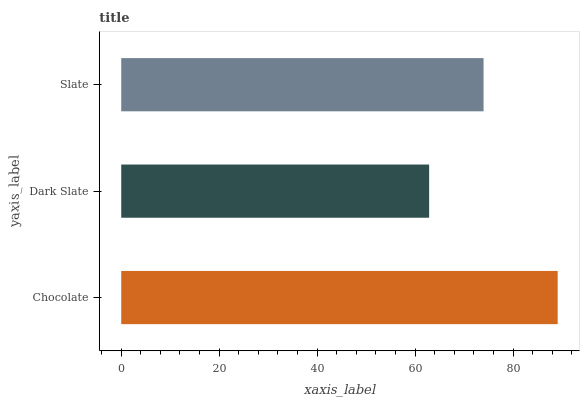Is Dark Slate the minimum?
Answer yes or no. Yes. Is Chocolate the maximum?
Answer yes or no. Yes. Is Slate the minimum?
Answer yes or no. No. Is Slate the maximum?
Answer yes or no. No. Is Slate greater than Dark Slate?
Answer yes or no. Yes. Is Dark Slate less than Slate?
Answer yes or no. Yes. Is Dark Slate greater than Slate?
Answer yes or no. No. Is Slate less than Dark Slate?
Answer yes or no. No. Is Slate the high median?
Answer yes or no. Yes. Is Slate the low median?
Answer yes or no. Yes. Is Chocolate the high median?
Answer yes or no. No. Is Chocolate the low median?
Answer yes or no. No. 